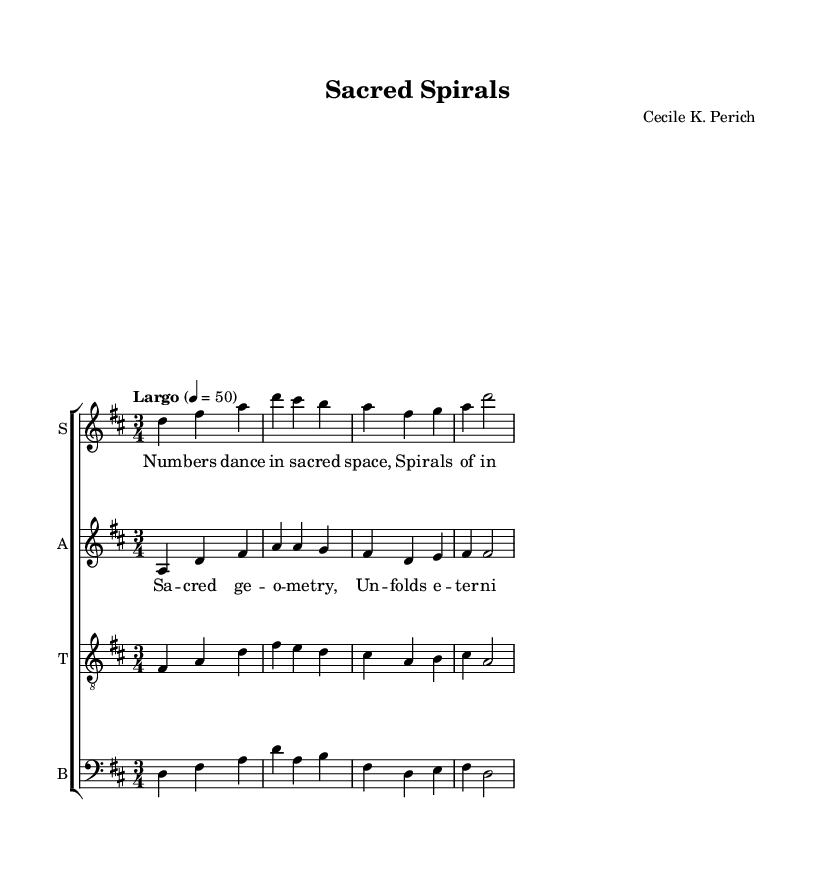What is the time signature of this music? The time signature is indicated at the beginning of the score. It shows that there are three beats in each measure.
Answer: 3/4 What key signature is used in this piece? The key signature is indicated at the beginning of the score, which shows two sharps. This corresponds to the key of D major.
Answer: D major What is the tempo marking for this music? The tempo marking is found at the beginning of the score, indicating the speed of the music. It specifies a Largo tempo at a quarter note equals 50.
Answer: Largo How many voices are present in this choral piece? By examining the score, we can see four distinct parts indicated: soprano, alto, tenor, and bass, indicating a four-voice arrangement.
Answer: Four What themes are explored in the lyrics of this piece? The lyrics suggest exploration of spiritual and mathematical themes, specifically mentioning "sacred space," "infinity," and "sacred geometry."
Answer: Spirituality and mathematics What is the primary lyrical device used in the verse? In the verse, there is a use of imagery that evokes the concept of movement and structure, particularly with "Numbers dance in sacred space," representing a connection to mathematics and spirituality.
Answer: Imagery 